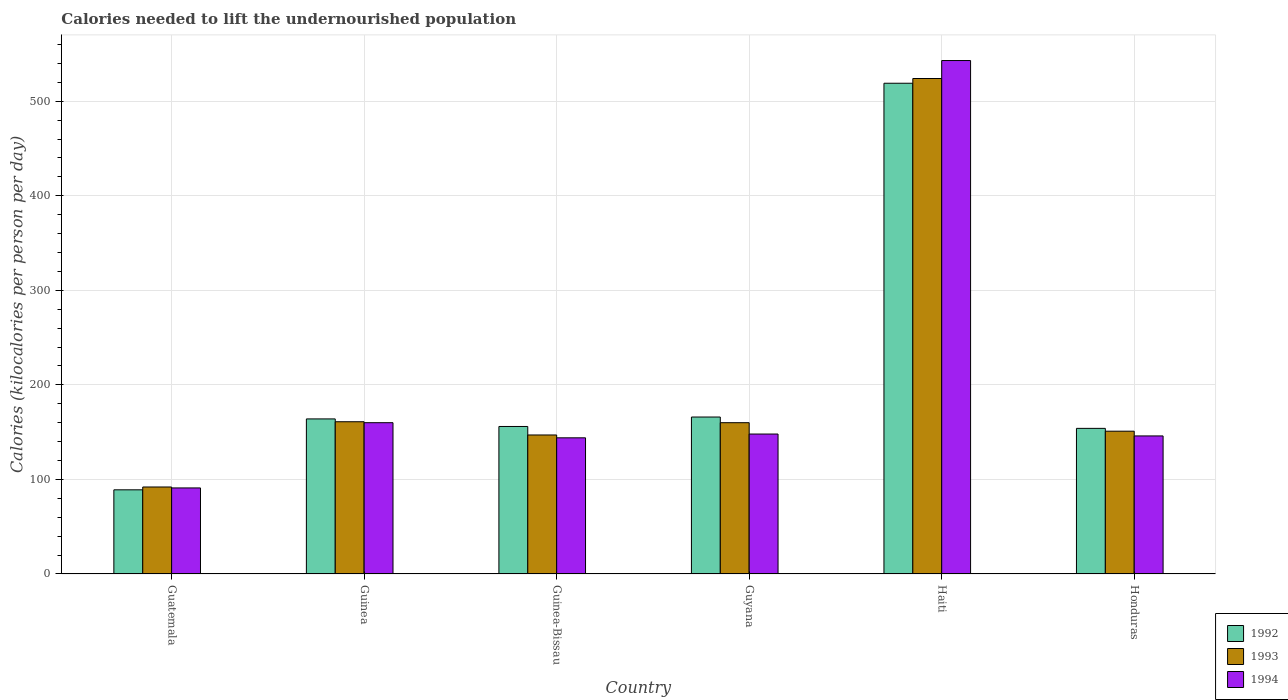How many groups of bars are there?
Give a very brief answer. 6. Are the number of bars per tick equal to the number of legend labels?
Provide a short and direct response. Yes. How many bars are there on the 6th tick from the left?
Make the answer very short. 3. What is the label of the 6th group of bars from the left?
Provide a short and direct response. Honduras. In how many cases, is the number of bars for a given country not equal to the number of legend labels?
Keep it short and to the point. 0. What is the total calories needed to lift the undernourished population in 1993 in Guyana?
Your answer should be very brief. 160. Across all countries, what is the maximum total calories needed to lift the undernourished population in 1994?
Your response must be concise. 543. Across all countries, what is the minimum total calories needed to lift the undernourished population in 1993?
Offer a terse response. 92. In which country was the total calories needed to lift the undernourished population in 1993 maximum?
Ensure brevity in your answer.  Haiti. In which country was the total calories needed to lift the undernourished population in 1992 minimum?
Provide a succinct answer. Guatemala. What is the total total calories needed to lift the undernourished population in 1992 in the graph?
Your response must be concise. 1248. What is the difference between the total calories needed to lift the undernourished population in 1994 in Guinea and that in Haiti?
Make the answer very short. -383. What is the average total calories needed to lift the undernourished population in 1992 per country?
Your answer should be very brief. 208. What is the difference between the total calories needed to lift the undernourished population of/in 1993 and total calories needed to lift the undernourished population of/in 1994 in Guinea-Bissau?
Provide a succinct answer. 3. What is the ratio of the total calories needed to lift the undernourished population in 1992 in Guatemala to that in Guyana?
Ensure brevity in your answer.  0.54. What is the difference between the highest and the second highest total calories needed to lift the undernourished population in 1992?
Provide a short and direct response. -2. What is the difference between the highest and the lowest total calories needed to lift the undernourished population in 1992?
Your response must be concise. 430. In how many countries, is the total calories needed to lift the undernourished population in 1994 greater than the average total calories needed to lift the undernourished population in 1994 taken over all countries?
Ensure brevity in your answer.  1. What does the 2nd bar from the left in Guyana represents?
Ensure brevity in your answer.  1993. What does the 3rd bar from the right in Guinea represents?
Make the answer very short. 1992. Is it the case that in every country, the sum of the total calories needed to lift the undernourished population in 1993 and total calories needed to lift the undernourished population in 1994 is greater than the total calories needed to lift the undernourished population in 1992?
Give a very brief answer. Yes. How many bars are there?
Your answer should be compact. 18. Are all the bars in the graph horizontal?
Keep it short and to the point. No. How many countries are there in the graph?
Provide a succinct answer. 6. What is the difference between two consecutive major ticks on the Y-axis?
Your answer should be very brief. 100. Does the graph contain grids?
Provide a short and direct response. Yes. Where does the legend appear in the graph?
Offer a very short reply. Bottom right. How many legend labels are there?
Keep it short and to the point. 3. What is the title of the graph?
Keep it short and to the point. Calories needed to lift the undernourished population. Does "1966" appear as one of the legend labels in the graph?
Make the answer very short. No. What is the label or title of the X-axis?
Make the answer very short. Country. What is the label or title of the Y-axis?
Your answer should be very brief. Calories (kilocalories per person per day). What is the Calories (kilocalories per person per day) of 1992 in Guatemala?
Keep it short and to the point. 89. What is the Calories (kilocalories per person per day) of 1993 in Guatemala?
Ensure brevity in your answer.  92. What is the Calories (kilocalories per person per day) of 1994 in Guatemala?
Provide a succinct answer. 91. What is the Calories (kilocalories per person per day) in 1992 in Guinea?
Ensure brevity in your answer.  164. What is the Calories (kilocalories per person per day) of 1993 in Guinea?
Offer a terse response. 161. What is the Calories (kilocalories per person per day) in 1994 in Guinea?
Keep it short and to the point. 160. What is the Calories (kilocalories per person per day) of 1992 in Guinea-Bissau?
Offer a very short reply. 156. What is the Calories (kilocalories per person per day) in 1993 in Guinea-Bissau?
Provide a short and direct response. 147. What is the Calories (kilocalories per person per day) in 1994 in Guinea-Bissau?
Your answer should be very brief. 144. What is the Calories (kilocalories per person per day) in 1992 in Guyana?
Give a very brief answer. 166. What is the Calories (kilocalories per person per day) of 1993 in Guyana?
Make the answer very short. 160. What is the Calories (kilocalories per person per day) of 1994 in Guyana?
Provide a short and direct response. 148. What is the Calories (kilocalories per person per day) in 1992 in Haiti?
Make the answer very short. 519. What is the Calories (kilocalories per person per day) in 1993 in Haiti?
Make the answer very short. 524. What is the Calories (kilocalories per person per day) in 1994 in Haiti?
Keep it short and to the point. 543. What is the Calories (kilocalories per person per day) in 1992 in Honduras?
Ensure brevity in your answer.  154. What is the Calories (kilocalories per person per day) of 1993 in Honduras?
Provide a short and direct response. 151. What is the Calories (kilocalories per person per day) of 1994 in Honduras?
Make the answer very short. 146. Across all countries, what is the maximum Calories (kilocalories per person per day) in 1992?
Provide a short and direct response. 519. Across all countries, what is the maximum Calories (kilocalories per person per day) in 1993?
Keep it short and to the point. 524. Across all countries, what is the maximum Calories (kilocalories per person per day) of 1994?
Offer a very short reply. 543. Across all countries, what is the minimum Calories (kilocalories per person per day) of 1992?
Your answer should be very brief. 89. Across all countries, what is the minimum Calories (kilocalories per person per day) in 1993?
Provide a succinct answer. 92. Across all countries, what is the minimum Calories (kilocalories per person per day) of 1994?
Ensure brevity in your answer.  91. What is the total Calories (kilocalories per person per day) in 1992 in the graph?
Your response must be concise. 1248. What is the total Calories (kilocalories per person per day) of 1993 in the graph?
Give a very brief answer. 1235. What is the total Calories (kilocalories per person per day) of 1994 in the graph?
Give a very brief answer. 1232. What is the difference between the Calories (kilocalories per person per day) in 1992 in Guatemala and that in Guinea?
Ensure brevity in your answer.  -75. What is the difference between the Calories (kilocalories per person per day) in 1993 in Guatemala and that in Guinea?
Your answer should be very brief. -69. What is the difference between the Calories (kilocalories per person per day) of 1994 in Guatemala and that in Guinea?
Give a very brief answer. -69. What is the difference between the Calories (kilocalories per person per day) in 1992 in Guatemala and that in Guinea-Bissau?
Your answer should be compact. -67. What is the difference between the Calories (kilocalories per person per day) of 1993 in Guatemala and that in Guinea-Bissau?
Your answer should be compact. -55. What is the difference between the Calories (kilocalories per person per day) of 1994 in Guatemala and that in Guinea-Bissau?
Your response must be concise. -53. What is the difference between the Calories (kilocalories per person per day) in 1992 in Guatemala and that in Guyana?
Your answer should be compact. -77. What is the difference between the Calories (kilocalories per person per day) of 1993 in Guatemala and that in Guyana?
Keep it short and to the point. -68. What is the difference between the Calories (kilocalories per person per day) in 1994 in Guatemala and that in Guyana?
Offer a terse response. -57. What is the difference between the Calories (kilocalories per person per day) of 1992 in Guatemala and that in Haiti?
Give a very brief answer. -430. What is the difference between the Calories (kilocalories per person per day) of 1993 in Guatemala and that in Haiti?
Your answer should be very brief. -432. What is the difference between the Calories (kilocalories per person per day) in 1994 in Guatemala and that in Haiti?
Your response must be concise. -452. What is the difference between the Calories (kilocalories per person per day) of 1992 in Guatemala and that in Honduras?
Make the answer very short. -65. What is the difference between the Calories (kilocalories per person per day) in 1993 in Guatemala and that in Honduras?
Provide a short and direct response. -59. What is the difference between the Calories (kilocalories per person per day) in 1994 in Guatemala and that in Honduras?
Provide a short and direct response. -55. What is the difference between the Calories (kilocalories per person per day) of 1992 in Guinea and that in Guinea-Bissau?
Ensure brevity in your answer.  8. What is the difference between the Calories (kilocalories per person per day) in 1992 in Guinea and that in Haiti?
Your answer should be compact. -355. What is the difference between the Calories (kilocalories per person per day) of 1993 in Guinea and that in Haiti?
Ensure brevity in your answer.  -363. What is the difference between the Calories (kilocalories per person per day) in 1994 in Guinea and that in Haiti?
Keep it short and to the point. -383. What is the difference between the Calories (kilocalories per person per day) in 1992 in Guinea and that in Honduras?
Your response must be concise. 10. What is the difference between the Calories (kilocalories per person per day) of 1993 in Guinea and that in Honduras?
Ensure brevity in your answer.  10. What is the difference between the Calories (kilocalories per person per day) of 1994 in Guinea and that in Honduras?
Provide a short and direct response. 14. What is the difference between the Calories (kilocalories per person per day) in 1992 in Guinea-Bissau and that in Guyana?
Offer a very short reply. -10. What is the difference between the Calories (kilocalories per person per day) of 1993 in Guinea-Bissau and that in Guyana?
Offer a terse response. -13. What is the difference between the Calories (kilocalories per person per day) in 1992 in Guinea-Bissau and that in Haiti?
Make the answer very short. -363. What is the difference between the Calories (kilocalories per person per day) in 1993 in Guinea-Bissau and that in Haiti?
Ensure brevity in your answer.  -377. What is the difference between the Calories (kilocalories per person per day) in 1994 in Guinea-Bissau and that in Haiti?
Your answer should be very brief. -399. What is the difference between the Calories (kilocalories per person per day) of 1993 in Guinea-Bissau and that in Honduras?
Your answer should be very brief. -4. What is the difference between the Calories (kilocalories per person per day) of 1992 in Guyana and that in Haiti?
Your response must be concise. -353. What is the difference between the Calories (kilocalories per person per day) of 1993 in Guyana and that in Haiti?
Your response must be concise. -364. What is the difference between the Calories (kilocalories per person per day) of 1994 in Guyana and that in Haiti?
Give a very brief answer. -395. What is the difference between the Calories (kilocalories per person per day) in 1992 in Guyana and that in Honduras?
Give a very brief answer. 12. What is the difference between the Calories (kilocalories per person per day) in 1993 in Guyana and that in Honduras?
Offer a terse response. 9. What is the difference between the Calories (kilocalories per person per day) in 1992 in Haiti and that in Honduras?
Give a very brief answer. 365. What is the difference between the Calories (kilocalories per person per day) of 1993 in Haiti and that in Honduras?
Offer a terse response. 373. What is the difference between the Calories (kilocalories per person per day) in 1994 in Haiti and that in Honduras?
Give a very brief answer. 397. What is the difference between the Calories (kilocalories per person per day) in 1992 in Guatemala and the Calories (kilocalories per person per day) in 1993 in Guinea?
Your response must be concise. -72. What is the difference between the Calories (kilocalories per person per day) of 1992 in Guatemala and the Calories (kilocalories per person per day) of 1994 in Guinea?
Your answer should be compact. -71. What is the difference between the Calories (kilocalories per person per day) in 1993 in Guatemala and the Calories (kilocalories per person per day) in 1994 in Guinea?
Keep it short and to the point. -68. What is the difference between the Calories (kilocalories per person per day) of 1992 in Guatemala and the Calories (kilocalories per person per day) of 1993 in Guinea-Bissau?
Provide a succinct answer. -58. What is the difference between the Calories (kilocalories per person per day) of 1992 in Guatemala and the Calories (kilocalories per person per day) of 1994 in Guinea-Bissau?
Offer a terse response. -55. What is the difference between the Calories (kilocalories per person per day) in 1993 in Guatemala and the Calories (kilocalories per person per day) in 1994 in Guinea-Bissau?
Offer a terse response. -52. What is the difference between the Calories (kilocalories per person per day) in 1992 in Guatemala and the Calories (kilocalories per person per day) in 1993 in Guyana?
Make the answer very short. -71. What is the difference between the Calories (kilocalories per person per day) in 1992 in Guatemala and the Calories (kilocalories per person per day) in 1994 in Guyana?
Offer a terse response. -59. What is the difference between the Calories (kilocalories per person per day) in 1993 in Guatemala and the Calories (kilocalories per person per day) in 1994 in Guyana?
Provide a short and direct response. -56. What is the difference between the Calories (kilocalories per person per day) of 1992 in Guatemala and the Calories (kilocalories per person per day) of 1993 in Haiti?
Provide a succinct answer. -435. What is the difference between the Calories (kilocalories per person per day) of 1992 in Guatemala and the Calories (kilocalories per person per day) of 1994 in Haiti?
Your answer should be compact. -454. What is the difference between the Calories (kilocalories per person per day) of 1993 in Guatemala and the Calories (kilocalories per person per day) of 1994 in Haiti?
Keep it short and to the point. -451. What is the difference between the Calories (kilocalories per person per day) in 1992 in Guatemala and the Calories (kilocalories per person per day) in 1993 in Honduras?
Provide a short and direct response. -62. What is the difference between the Calories (kilocalories per person per day) in 1992 in Guatemala and the Calories (kilocalories per person per day) in 1994 in Honduras?
Provide a succinct answer. -57. What is the difference between the Calories (kilocalories per person per day) in 1993 in Guatemala and the Calories (kilocalories per person per day) in 1994 in Honduras?
Ensure brevity in your answer.  -54. What is the difference between the Calories (kilocalories per person per day) of 1992 in Guinea and the Calories (kilocalories per person per day) of 1994 in Guyana?
Your answer should be very brief. 16. What is the difference between the Calories (kilocalories per person per day) in 1993 in Guinea and the Calories (kilocalories per person per day) in 1994 in Guyana?
Your answer should be very brief. 13. What is the difference between the Calories (kilocalories per person per day) in 1992 in Guinea and the Calories (kilocalories per person per day) in 1993 in Haiti?
Make the answer very short. -360. What is the difference between the Calories (kilocalories per person per day) in 1992 in Guinea and the Calories (kilocalories per person per day) in 1994 in Haiti?
Give a very brief answer. -379. What is the difference between the Calories (kilocalories per person per day) in 1993 in Guinea and the Calories (kilocalories per person per day) in 1994 in Haiti?
Provide a short and direct response. -382. What is the difference between the Calories (kilocalories per person per day) in 1992 in Guinea and the Calories (kilocalories per person per day) in 1994 in Honduras?
Ensure brevity in your answer.  18. What is the difference between the Calories (kilocalories per person per day) in 1993 in Guinea and the Calories (kilocalories per person per day) in 1994 in Honduras?
Provide a short and direct response. 15. What is the difference between the Calories (kilocalories per person per day) of 1992 in Guinea-Bissau and the Calories (kilocalories per person per day) of 1993 in Guyana?
Provide a short and direct response. -4. What is the difference between the Calories (kilocalories per person per day) of 1992 in Guinea-Bissau and the Calories (kilocalories per person per day) of 1994 in Guyana?
Ensure brevity in your answer.  8. What is the difference between the Calories (kilocalories per person per day) of 1992 in Guinea-Bissau and the Calories (kilocalories per person per day) of 1993 in Haiti?
Your answer should be compact. -368. What is the difference between the Calories (kilocalories per person per day) in 1992 in Guinea-Bissau and the Calories (kilocalories per person per day) in 1994 in Haiti?
Offer a terse response. -387. What is the difference between the Calories (kilocalories per person per day) in 1993 in Guinea-Bissau and the Calories (kilocalories per person per day) in 1994 in Haiti?
Keep it short and to the point. -396. What is the difference between the Calories (kilocalories per person per day) in 1992 in Guinea-Bissau and the Calories (kilocalories per person per day) in 1993 in Honduras?
Your answer should be compact. 5. What is the difference between the Calories (kilocalories per person per day) in 1992 in Guinea-Bissau and the Calories (kilocalories per person per day) in 1994 in Honduras?
Your answer should be very brief. 10. What is the difference between the Calories (kilocalories per person per day) in 1992 in Guyana and the Calories (kilocalories per person per day) in 1993 in Haiti?
Offer a terse response. -358. What is the difference between the Calories (kilocalories per person per day) of 1992 in Guyana and the Calories (kilocalories per person per day) of 1994 in Haiti?
Your answer should be compact. -377. What is the difference between the Calories (kilocalories per person per day) in 1993 in Guyana and the Calories (kilocalories per person per day) in 1994 in Haiti?
Offer a very short reply. -383. What is the difference between the Calories (kilocalories per person per day) of 1993 in Guyana and the Calories (kilocalories per person per day) of 1994 in Honduras?
Keep it short and to the point. 14. What is the difference between the Calories (kilocalories per person per day) in 1992 in Haiti and the Calories (kilocalories per person per day) in 1993 in Honduras?
Make the answer very short. 368. What is the difference between the Calories (kilocalories per person per day) of 1992 in Haiti and the Calories (kilocalories per person per day) of 1994 in Honduras?
Ensure brevity in your answer.  373. What is the difference between the Calories (kilocalories per person per day) in 1993 in Haiti and the Calories (kilocalories per person per day) in 1994 in Honduras?
Make the answer very short. 378. What is the average Calories (kilocalories per person per day) of 1992 per country?
Ensure brevity in your answer.  208. What is the average Calories (kilocalories per person per day) of 1993 per country?
Make the answer very short. 205.83. What is the average Calories (kilocalories per person per day) of 1994 per country?
Keep it short and to the point. 205.33. What is the difference between the Calories (kilocalories per person per day) in 1992 and Calories (kilocalories per person per day) in 1994 in Guatemala?
Offer a very short reply. -2. What is the difference between the Calories (kilocalories per person per day) of 1992 and Calories (kilocalories per person per day) of 1993 in Guinea?
Provide a short and direct response. 3. What is the difference between the Calories (kilocalories per person per day) in 1993 and Calories (kilocalories per person per day) in 1994 in Guinea?
Ensure brevity in your answer.  1. What is the difference between the Calories (kilocalories per person per day) in 1992 and Calories (kilocalories per person per day) in 1993 in Guyana?
Keep it short and to the point. 6. What is the difference between the Calories (kilocalories per person per day) of 1992 and Calories (kilocalories per person per day) of 1993 in Haiti?
Give a very brief answer. -5. What is the difference between the Calories (kilocalories per person per day) in 1992 and Calories (kilocalories per person per day) in 1993 in Honduras?
Give a very brief answer. 3. What is the ratio of the Calories (kilocalories per person per day) in 1992 in Guatemala to that in Guinea?
Keep it short and to the point. 0.54. What is the ratio of the Calories (kilocalories per person per day) of 1994 in Guatemala to that in Guinea?
Your answer should be compact. 0.57. What is the ratio of the Calories (kilocalories per person per day) in 1992 in Guatemala to that in Guinea-Bissau?
Keep it short and to the point. 0.57. What is the ratio of the Calories (kilocalories per person per day) in 1993 in Guatemala to that in Guinea-Bissau?
Ensure brevity in your answer.  0.63. What is the ratio of the Calories (kilocalories per person per day) of 1994 in Guatemala to that in Guinea-Bissau?
Ensure brevity in your answer.  0.63. What is the ratio of the Calories (kilocalories per person per day) of 1992 in Guatemala to that in Guyana?
Your answer should be very brief. 0.54. What is the ratio of the Calories (kilocalories per person per day) of 1993 in Guatemala to that in Guyana?
Your response must be concise. 0.57. What is the ratio of the Calories (kilocalories per person per day) in 1994 in Guatemala to that in Guyana?
Your answer should be very brief. 0.61. What is the ratio of the Calories (kilocalories per person per day) in 1992 in Guatemala to that in Haiti?
Your response must be concise. 0.17. What is the ratio of the Calories (kilocalories per person per day) of 1993 in Guatemala to that in Haiti?
Provide a succinct answer. 0.18. What is the ratio of the Calories (kilocalories per person per day) of 1994 in Guatemala to that in Haiti?
Provide a succinct answer. 0.17. What is the ratio of the Calories (kilocalories per person per day) in 1992 in Guatemala to that in Honduras?
Give a very brief answer. 0.58. What is the ratio of the Calories (kilocalories per person per day) of 1993 in Guatemala to that in Honduras?
Offer a very short reply. 0.61. What is the ratio of the Calories (kilocalories per person per day) of 1994 in Guatemala to that in Honduras?
Provide a short and direct response. 0.62. What is the ratio of the Calories (kilocalories per person per day) in 1992 in Guinea to that in Guinea-Bissau?
Offer a very short reply. 1.05. What is the ratio of the Calories (kilocalories per person per day) in 1993 in Guinea to that in Guinea-Bissau?
Provide a succinct answer. 1.1. What is the ratio of the Calories (kilocalories per person per day) in 1994 in Guinea to that in Guinea-Bissau?
Ensure brevity in your answer.  1.11. What is the ratio of the Calories (kilocalories per person per day) in 1994 in Guinea to that in Guyana?
Offer a terse response. 1.08. What is the ratio of the Calories (kilocalories per person per day) in 1992 in Guinea to that in Haiti?
Make the answer very short. 0.32. What is the ratio of the Calories (kilocalories per person per day) of 1993 in Guinea to that in Haiti?
Your response must be concise. 0.31. What is the ratio of the Calories (kilocalories per person per day) in 1994 in Guinea to that in Haiti?
Keep it short and to the point. 0.29. What is the ratio of the Calories (kilocalories per person per day) of 1992 in Guinea to that in Honduras?
Keep it short and to the point. 1.06. What is the ratio of the Calories (kilocalories per person per day) in 1993 in Guinea to that in Honduras?
Offer a very short reply. 1.07. What is the ratio of the Calories (kilocalories per person per day) in 1994 in Guinea to that in Honduras?
Your response must be concise. 1.1. What is the ratio of the Calories (kilocalories per person per day) in 1992 in Guinea-Bissau to that in Guyana?
Give a very brief answer. 0.94. What is the ratio of the Calories (kilocalories per person per day) in 1993 in Guinea-Bissau to that in Guyana?
Ensure brevity in your answer.  0.92. What is the ratio of the Calories (kilocalories per person per day) in 1994 in Guinea-Bissau to that in Guyana?
Ensure brevity in your answer.  0.97. What is the ratio of the Calories (kilocalories per person per day) in 1992 in Guinea-Bissau to that in Haiti?
Provide a short and direct response. 0.3. What is the ratio of the Calories (kilocalories per person per day) of 1993 in Guinea-Bissau to that in Haiti?
Keep it short and to the point. 0.28. What is the ratio of the Calories (kilocalories per person per day) of 1994 in Guinea-Bissau to that in Haiti?
Provide a succinct answer. 0.27. What is the ratio of the Calories (kilocalories per person per day) in 1993 in Guinea-Bissau to that in Honduras?
Keep it short and to the point. 0.97. What is the ratio of the Calories (kilocalories per person per day) in 1994 in Guinea-Bissau to that in Honduras?
Make the answer very short. 0.99. What is the ratio of the Calories (kilocalories per person per day) in 1992 in Guyana to that in Haiti?
Ensure brevity in your answer.  0.32. What is the ratio of the Calories (kilocalories per person per day) in 1993 in Guyana to that in Haiti?
Offer a very short reply. 0.31. What is the ratio of the Calories (kilocalories per person per day) of 1994 in Guyana to that in Haiti?
Keep it short and to the point. 0.27. What is the ratio of the Calories (kilocalories per person per day) in 1992 in Guyana to that in Honduras?
Provide a short and direct response. 1.08. What is the ratio of the Calories (kilocalories per person per day) in 1993 in Guyana to that in Honduras?
Offer a terse response. 1.06. What is the ratio of the Calories (kilocalories per person per day) of 1994 in Guyana to that in Honduras?
Keep it short and to the point. 1.01. What is the ratio of the Calories (kilocalories per person per day) in 1992 in Haiti to that in Honduras?
Your response must be concise. 3.37. What is the ratio of the Calories (kilocalories per person per day) in 1993 in Haiti to that in Honduras?
Your answer should be very brief. 3.47. What is the ratio of the Calories (kilocalories per person per day) in 1994 in Haiti to that in Honduras?
Offer a very short reply. 3.72. What is the difference between the highest and the second highest Calories (kilocalories per person per day) of 1992?
Give a very brief answer. 353. What is the difference between the highest and the second highest Calories (kilocalories per person per day) of 1993?
Your answer should be very brief. 363. What is the difference between the highest and the second highest Calories (kilocalories per person per day) in 1994?
Ensure brevity in your answer.  383. What is the difference between the highest and the lowest Calories (kilocalories per person per day) in 1992?
Your answer should be compact. 430. What is the difference between the highest and the lowest Calories (kilocalories per person per day) in 1993?
Provide a short and direct response. 432. What is the difference between the highest and the lowest Calories (kilocalories per person per day) of 1994?
Your answer should be very brief. 452. 